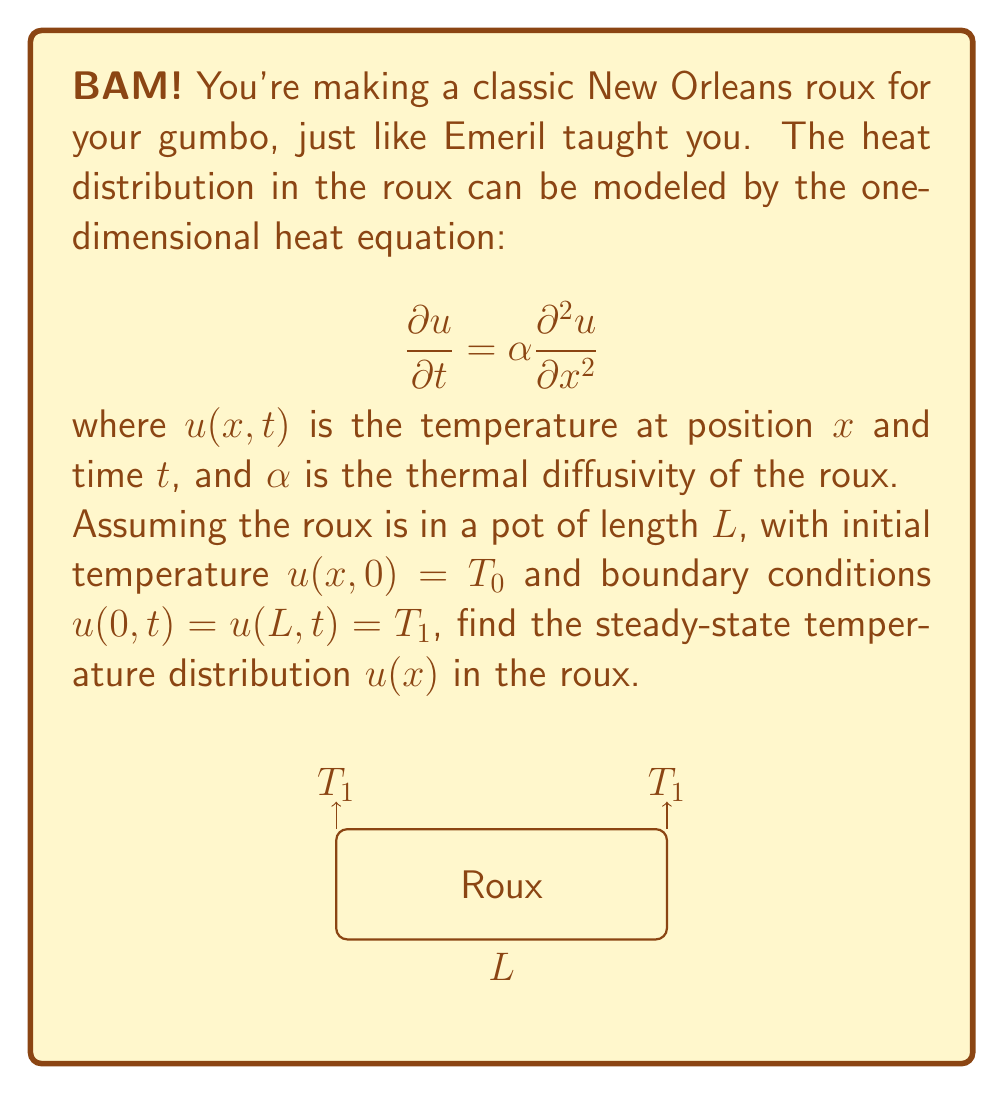Solve this math problem. Let's approach this step-by-step:

1) For the steady-state solution, the temperature doesn't change with time. So, $\frac{\partial u}{\partial t} = 0$.

2) The heat equation then becomes:

   $$0 = \alpha \frac{d^2 u}{dx^2}$$

3) Integrating twice:

   $$\frac{du}{dx} = C_1$$
   $$u(x) = C_1x + C_2$$

4) Now, we apply the boundary conditions:
   
   At $x = 0$: $u(0) = T_1 = C_2$
   At $x = L$: $u(L) = T_1 = C_1L + C_2$

5) From these conditions:

   $$C_2 = T_1$$
   $$C_1L + T_1 = T_1$$
   $$C_1L = 0$$
   $$C_1 = 0$$

6) Therefore, the steady-state solution is:

   $$u(x) = T_1$$

This means that at steady state, the temperature throughout the roux will be uniform and equal to the boundary temperature $T_1$.
Answer: $u(x) = T_1$ 